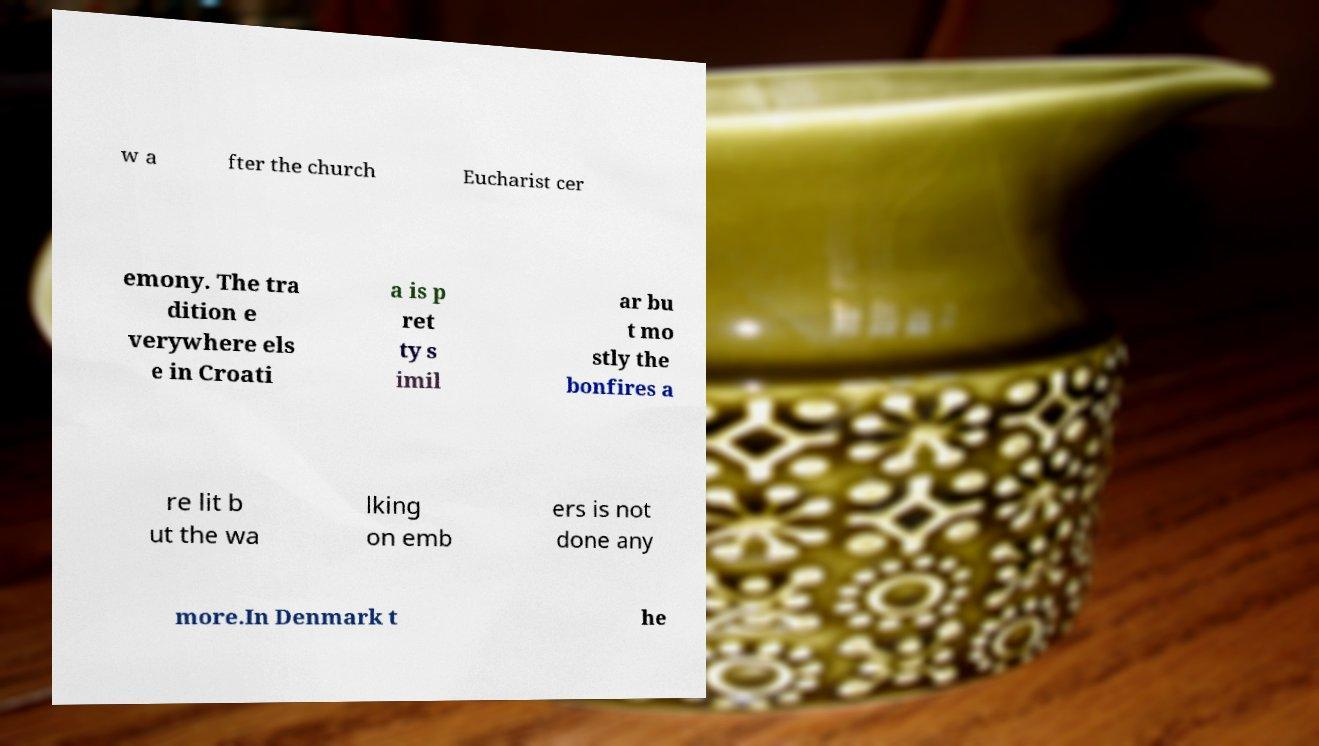Can you accurately transcribe the text from the provided image for me? w a fter the church Eucharist cer emony. The tra dition e verywhere els e in Croati a is p ret ty s imil ar bu t mo stly the bonfires a re lit b ut the wa lking on emb ers is not done any more.In Denmark t he 